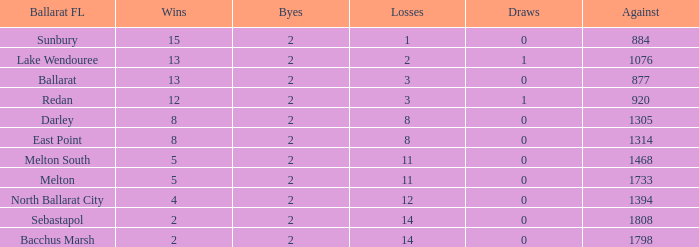In how many instances is the "byes" value smaller than 2 for "against"? None. 